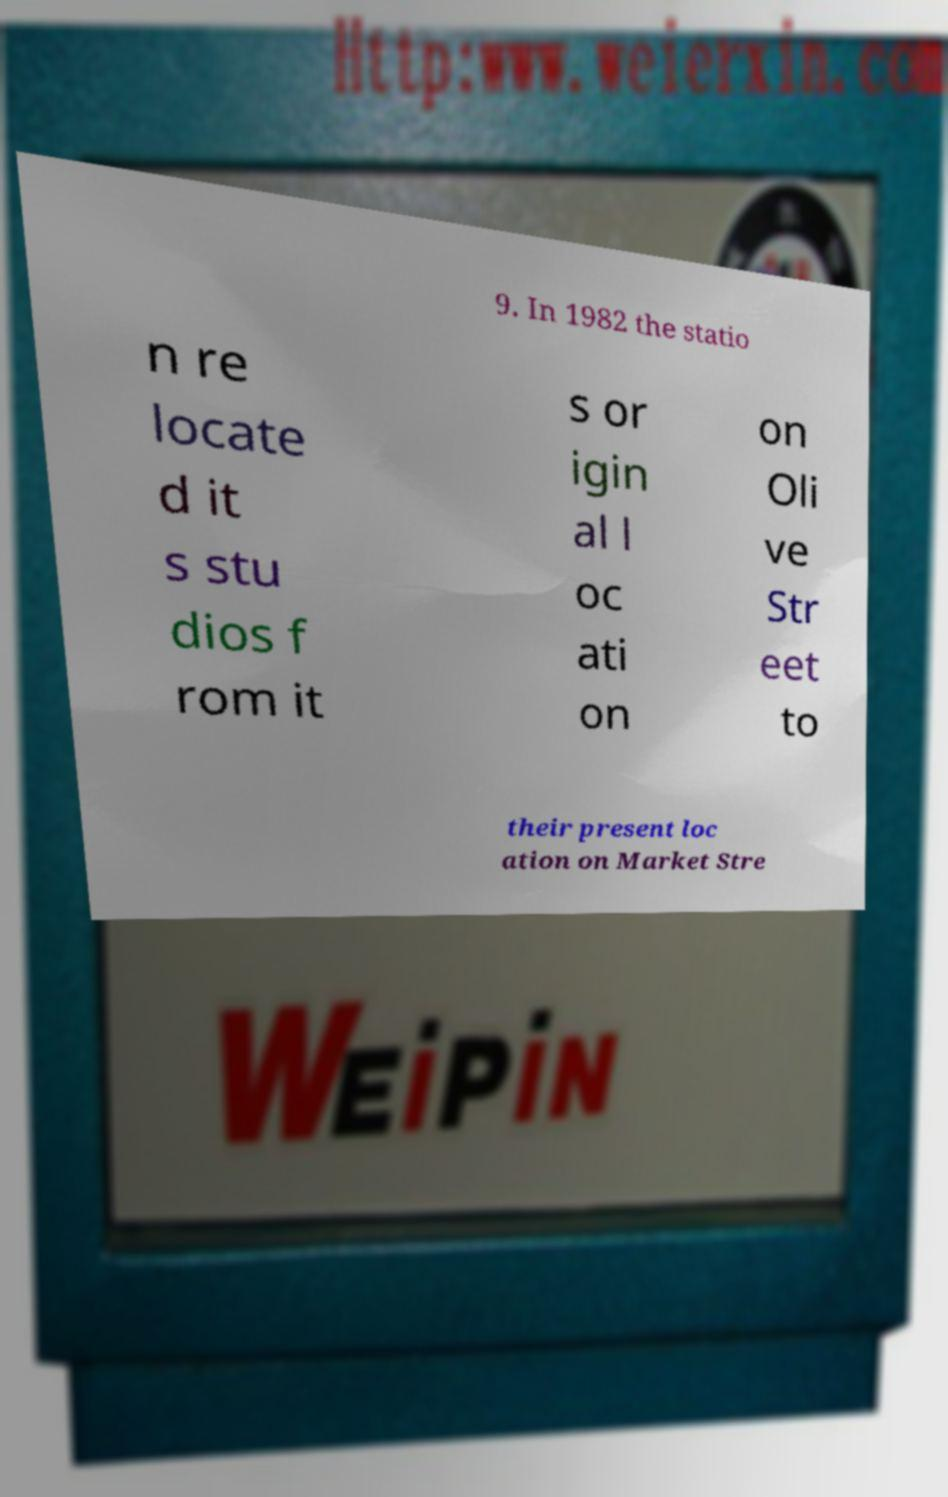What messages or text are displayed in this image? I need them in a readable, typed format. 9. In 1982 the statio n re locate d it s stu dios f rom it s or igin al l oc ati on on Oli ve Str eet to their present loc ation on Market Stre 